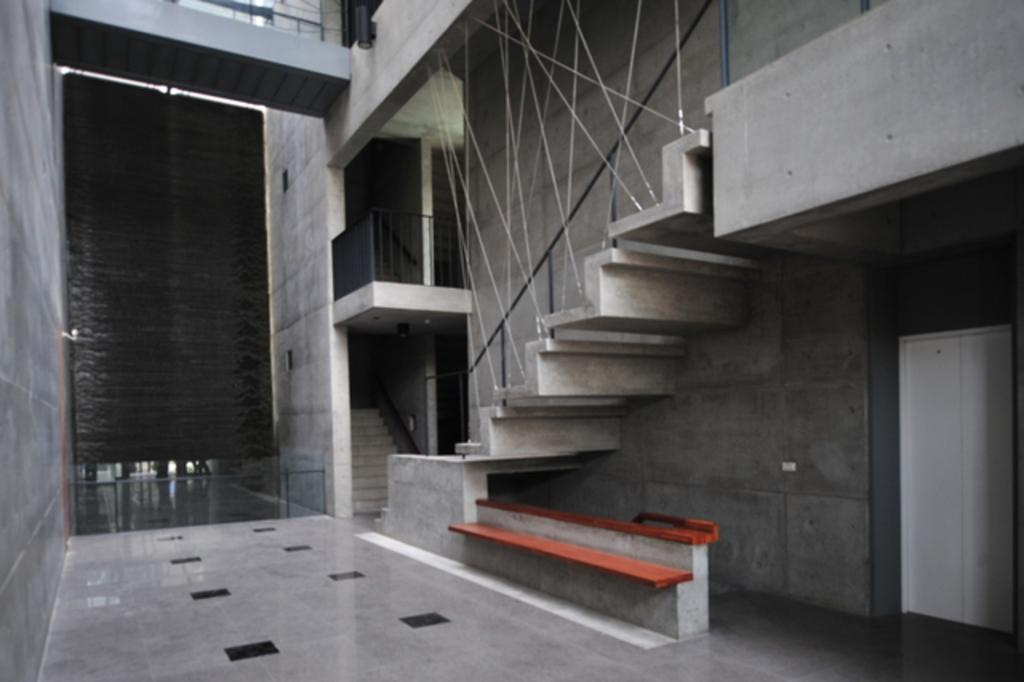What type of architectural features can be seen in the image? There are doors, staircases, poles, and a grille visible in the image. What type of surface is present in the image? The floor is visible in the image. What type of seating is present in the image? There is a bench in the image. What type of barrier is present in the image? There is a wall in the image. Can you see any ants crawling on the bench in the image? There are no ants visible in the image. What type of cable is connected to the poles in the image? There are no cables connected to the poles in the image. 